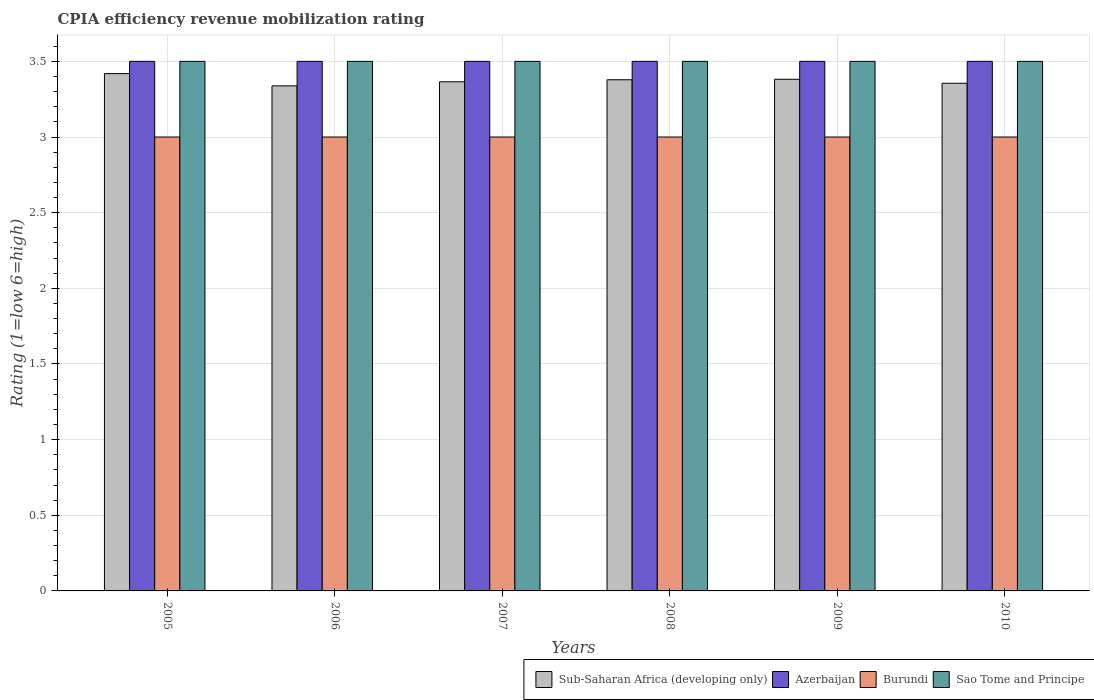How many different coloured bars are there?
Make the answer very short. 4. How many groups of bars are there?
Keep it short and to the point. 6. How many bars are there on the 5th tick from the right?
Provide a short and direct response. 4. What is the label of the 4th group of bars from the left?
Offer a very short reply. 2008. What is the CPIA rating in Sub-Saharan Africa (developing only) in 2008?
Offer a very short reply. 3.38. In which year was the CPIA rating in Sub-Saharan Africa (developing only) maximum?
Provide a succinct answer. 2005. In which year was the CPIA rating in Azerbaijan minimum?
Your answer should be very brief. 2005. What is the total CPIA rating in Sub-Saharan Africa (developing only) in the graph?
Keep it short and to the point. 20.24. What is the difference between the CPIA rating in Sub-Saharan Africa (developing only) in 2007 and that in 2009?
Offer a very short reply. -0.02. What is the difference between the CPIA rating in Burundi in 2008 and the CPIA rating in Sub-Saharan Africa (developing only) in 2010?
Your answer should be compact. -0.36. What is the average CPIA rating in Sub-Saharan Africa (developing only) per year?
Give a very brief answer. 3.37. In the year 2009, what is the difference between the CPIA rating in Burundi and CPIA rating in Sub-Saharan Africa (developing only)?
Offer a terse response. -0.38. What is the difference between the highest and the second highest CPIA rating in Sub-Saharan Africa (developing only)?
Your answer should be very brief. 0.04. Is it the case that in every year, the sum of the CPIA rating in Azerbaijan and CPIA rating in Sao Tome and Principe is greater than the sum of CPIA rating in Sub-Saharan Africa (developing only) and CPIA rating in Burundi?
Provide a short and direct response. Yes. What does the 4th bar from the left in 2009 represents?
Offer a very short reply. Sao Tome and Principe. What does the 2nd bar from the right in 2005 represents?
Provide a succinct answer. Burundi. How many years are there in the graph?
Offer a very short reply. 6. Does the graph contain any zero values?
Ensure brevity in your answer.  No. Does the graph contain grids?
Ensure brevity in your answer.  Yes. What is the title of the graph?
Your answer should be compact. CPIA efficiency revenue mobilization rating. Does "Timor-Leste" appear as one of the legend labels in the graph?
Provide a short and direct response. No. What is the label or title of the X-axis?
Your response must be concise. Years. What is the label or title of the Y-axis?
Provide a succinct answer. Rating (1=low 6=high). What is the Rating (1=low 6=high) of Sub-Saharan Africa (developing only) in 2005?
Your answer should be compact. 3.42. What is the Rating (1=low 6=high) in Burundi in 2005?
Provide a succinct answer. 3. What is the Rating (1=low 6=high) of Sao Tome and Principe in 2005?
Your response must be concise. 3.5. What is the Rating (1=low 6=high) of Sub-Saharan Africa (developing only) in 2006?
Your answer should be very brief. 3.34. What is the Rating (1=low 6=high) of Burundi in 2006?
Make the answer very short. 3. What is the Rating (1=low 6=high) of Sub-Saharan Africa (developing only) in 2007?
Make the answer very short. 3.36. What is the Rating (1=low 6=high) in Sao Tome and Principe in 2007?
Give a very brief answer. 3.5. What is the Rating (1=low 6=high) of Sub-Saharan Africa (developing only) in 2008?
Your answer should be compact. 3.38. What is the Rating (1=low 6=high) of Azerbaijan in 2008?
Keep it short and to the point. 3.5. What is the Rating (1=low 6=high) of Burundi in 2008?
Ensure brevity in your answer.  3. What is the Rating (1=low 6=high) of Sub-Saharan Africa (developing only) in 2009?
Provide a short and direct response. 3.38. What is the Rating (1=low 6=high) of Azerbaijan in 2009?
Keep it short and to the point. 3.5. What is the Rating (1=low 6=high) of Burundi in 2009?
Keep it short and to the point. 3. What is the Rating (1=low 6=high) of Sub-Saharan Africa (developing only) in 2010?
Your answer should be compact. 3.36. What is the Rating (1=low 6=high) in Azerbaijan in 2010?
Your response must be concise. 3.5. What is the Rating (1=low 6=high) in Sao Tome and Principe in 2010?
Offer a very short reply. 3.5. Across all years, what is the maximum Rating (1=low 6=high) in Sub-Saharan Africa (developing only)?
Offer a very short reply. 3.42. Across all years, what is the maximum Rating (1=low 6=high) of Burundi?
Ensure brevity in your answer.  3. Across all years, what is the minimum Rating (1=low 6=high) in Sub-Saharan Africa (developing only)?
Provide a succinct answer. 3.34. Across all years, what is the minimum Rating (1=low 6=high) of Sao Tome and Principe?
Your answer should be very brief. 3.5. What is the total Rating (1=low 6=high) of Sub-Saharan Africa (developing only) in the graph?
Give a very brief answer. 20.24. What is the total Rating (1=low 6=high) of Burundi in the graph?
Your answer should be very brief. 18. What is the total Rating (1=low 6=high) in Sao Tome and Principe in the graph?
Provide a succinct answer. 21. What is the difference between the Rating (1=low 6=high) in Sub-Saharan Africa (developing only) in 2005 and that in 2006?
Ensure brevity in your answer.  0.08. What is the difference between the Rating (1=low 6=high) in Azerbaijan in 2005 and that in 2006?
Make the answer very short. 0. What is the difference between the Rating (1=low 6=high) of Sub-Saharan Africa (developing only) in 2005 and that in 2007?
Provide a short and direct response. 0.05. What is the difference between the Rating (1=low 6=high) of Azerbaijan in 2005 and that in 2007?
Offer a very short reply. 0. What is the difference between the Rating (1=low 6=high) in Sub-Saharan Africa (developing only) in 2005 and that in 2008?
Your answer should be compact. 0.04. What is the difference between the Rating (1=low 6=high) of Burundi in 2005 and that in 2008?
Offer a very short reply. 0. What is the difference between the Rating (1=low 6=high) of Sao Tome and Principe in 2005 and that in 2008?
Your answer should be compact. 0. What is the difference between the Rating (1=low 6=high) of Sub-Saharan Africa (developing only) in 2005 and that in 2009?
Make the answer very short. 0.04. What is the difference between the Rating (1=low 6=high) of Sao Tome and Principe in 2005 and that in 2009?
Your answer should be very brief. 0. What is the difference between the Rating (1=low 6=high) in Sub-Saharan Africa (developing only) in 2005 and that in 2010?
Your answer should be compact. 0.06. What is the difference between the Rating (1=low 6=high) in Sub-Saharan Africa (developing only) in 2006 and that in 2007?
Offer a terse response. -0.03. What is the difference between the Rating (1=low 6=high) of Azerbaijan in 2006 and that in 2007?
Your response must be concise. 0. What is the difference between the Rating (1=low 6=high) of Burundi in 2006 and that in 2007?
Provide a succinct answer. 0. What is the difference between the Rating (1=low 6=high) in Sao Tome and Principe in 2006 and that in 2007?
Keep it short and to the point. 0. What is the difference between the Rating (1=low 6=high) in Sub-Saharan Africa (developing only) in 2006 and that in 2008?
Your answer should be very brief. -0.04. What is the difference between the Rating (1=low 6=high) of Sao Tome and Principe in 2006 and that in 2008?
Your response must be concise. 0. What is the difference between the Rating (1=low 6=high) in Sub-Saharan Africa (developing only) in 2006 and that in 2009?
Offer a very short reply. -0.04. What is the difference between the Rating (1=low 6=high) of Burundi in 2006 and that in 2009?
Offer a very short reply. 0. What is the difference between the Rating (1=low 6=high) in Sao Tome and Principe in 2006 and that in 2009?
Give a very brief answer. 0. What is the difference between the Rating (1=low 6=high) of Sub-Saharan Africa (developing only) in 2006 and that in 2010?
Provide a short and direct response. -0.02. What is the difference between the Rating (1=low 6=high) of Azerbaijan in 2006 and that in 2010?
Your answer should be compact. 0. What is the difference between the Rating (1=low 6=high) in Burundi in 2006 and that in 2010?
Provide a succinct answer. 0. What is the difference between the Rating (1=low 6=high) in Sao Tome and Principe in 2006 and that in 2010?
Offer a terse response. 0. What is the difference between the Rating (1=low 6=high) in Sub-Saharan Africa (developing only) in 2007 and that in 2008?
Keep it short and to the point. -0.01. What is the difference between the Rating (1=low 6=high) of Azerbaijan in 2007 and that in 2008?
Ensure brevity in your answer.  0. What is the difference between the Rating (1=low 6=high) of Sub-Saharan Africa (developing only) in 2007 and that in 2009?
Ensure brevity in your answer.  -0.02. What is the difference between the Rating (1=low 6=high) in Azerbaijan in 2007 and that in 2009?
Your answer should be compact. 0. What is the difference between the Rating (1=low 6=high) in Burundi in 2007 and that in 2009?
Keep it short and to the point. 0. What is the difference between the Rating (1=low 6=high) in Sao Tome and Principe in 2007 and that in 2009?
Give a very brief answer. 0. What is the difference between the Rating (1=low 6=high) of Sub-Saharan Africa (developing only) in 2007 and that in 2010?
Offer a very short reply. 0.01. What is the difference between the Rating (1=low 6=high) in Azerbaijan in 2007 and that in 2010?
Your response must be concise. 0. What is the difference between the Rating (1=low 6=high) in Sub-Saharan Africa (developing only) in 2008 and that in 2009?
Ensure brevity in your answer.  -0. What is the difference between the Rating (1=low 6=high) in Sub-Saharan Africa (developing only) in 2008 and that in 2010?
Your response must be concise. 0.02. What is the difference between the Rating (1=low 6=high) in Burundi in 2008 and that in 2010?
Your answer should be very brief. 0. What is the difference between the Rating (1=low 6=high) in Sub-Saharan Africa (developing only) in 2009 and that in 2010?
Give a very brief answer. 0.03. What is the difference between the Rating (1=low 6=high) in Azerbaijan in 2009 and that in 2010?
Make the answer very short. 0. What is the difference between the Rating (1=low 6=high) of Sub-Saharan Africa (developing only) in 2005 and the Rating (1=low 6=high) of Azerbaijan in 2006?
Offer a terse response. -0.08. What is the difference between the Rating (1=low 6=high) of Sub-Saharan Africa (developing only) in 2005 and the Rating (1=low 6=high) of Burundi in 2006?
Make the answer very short. 0.42. What is the difference between the Rating (1=low 6=high) in Sub-Saharan Africa (developing only) in 2005 and the Rating (1=low 6=high) in Sao Tome and Principe in 2006?
Offer a very short reply. -0.08. What is the difference between the Rating (1=low 6=high) in Azerbaijan in 2005 and the Rating (1=low 6=high) in Sao Tome and Principe in 2006?
Your response must be concise. 0. What is the difference between the Rating (1=low 6=high) of Burundi in 2005 and the Rating (1=low 6=high) of Sao Tome and Principe in 2006?
Provide a short and direct response. -0.5. What is the difference between the Rating (1=low 6=high) in Sub-Saharan Africa (developing only) in 2005 and the Rating (1=low 6=high) in Azerbaijan in 2007?
Offer a terse response. -0.08. What is the difference between the Rating (1=low 6=high) of Sub-Saharan Africa (developing only) in 2005 and the Rating (1=low 6=high) of Burundi in 2007?
Your answer should be compact. 0.42. What is the difference between the Rating (1=low 6=high) of Sub-Saharan Africa (developing only) in 2005 and the Rating (1=low 6=high) of Sao Tome and Principe in 2007?
Offer a very short reply. -0.08. What is the difference between the Rating (1=low 6=high) in Azerbaijan in 2005 and the Rating (1=low 6=high) in Burundi in 2007?
Your response must be concise. 0.5. What is the difference between the Rating (1=low 6=high) in Azerbaijan in 2005 and the Rating (1=low 6=high) in Sao Tome and Principe in 2007?
Give a very brief answer. 0. What is the difference between the Rating (1=low 6=high) in Burundi in 2005 and the Rating (1=low 6=high) in Sao Tome and Principe in 2007?
Your answer should be very brief. -0.5. What is the difference between the Rating (1=low 6=high) in Sub-Saharan Africa (developing only) in 2005 and the Rating (1=low 6=high) in Azerbaijan in 2008?
Keep it short and to the point. -0.08. What is the difference between the Rating (1=low 6=high) of Sub-Saharan Africa (developing only) in 2005 and the Rating (1=low 6=high) of Burundi in 2008?
Keep it short and to the point. 0.42. What is the difference between the Rating (1=low 6=high) of Sub-Saharan Africa (developing only) in 2005 and the Rating (1=low 6=high) of Sao Tome and Principe in 2008?
Keep it short and to the point. -0.08. What is the difference between the Rating (1=low 6=high) in Azerbaijan in 2005 and the Rating (1=low 6=high) in Burundi in 2008?
Your answer should be very brief. 0.5. What is the difference between the Rating (1=low 6=high) of Burundi in 2005 and the Rating (1=low 6=high) of Sao Tome and Principe in 2008?
Offer a terse response. -0.5. What is the difference between the Rating (1=low 6=high) in Sub-Saharan Africa (developing only) in 2005 and the Rating (1=low 6=high) in Azerbaijan in 2009?
Ensure brevity in your answer.  -0.08. What is the difference between the Rating (1=low 6=high) in Sub-Saharan Africa (developing only) in 2005 and the Rating (1=low 6=high) in Burundi in 2009?
Make the answer very short. 0.42. What is the difference between the Rating (1=low 6=high) of Sub-Saharan Africa (developing only) in 2005 and the Rating (1=low 6=high) of Sao Tome and Principe in 2009?
Ensure brevity in your answer.  -0.08. What is the difference between the Rating (1=low 6=high) of Sub-Saharan Africa (developing only) in 2005 and the Rating (1=low 6=high) of Azerbaijan in 2010?
Your answer should be compact. -0.08. What is the difference between the Rating (1=low 6=high) of Sub-Saharan Africa (developing only) in 2005 and the Rating (1=low 6=high) of Burundi in 2010?
Provide a succinct answer. 0.42. What is the difference between the Rating (1=low 6=high) of Sub-Saharan Africa (developing only) in 2005 and the Rating (1=low 6=high) of Sao Tome and Principe in 2010?
Give a very brief answer. -0.08. What is the difference between the Rating (1=low 6=high) in Azerbaijan in 2005 and the Rating (1=low 6=high) in Burundi in 2010?
Your answer should be compact. 0.5. What is the difference between the Rating (1=low 6=high) in Burundi in 2005 and the Rating (1=low 6=high) in Sao Tome and Principe in 2010?
Keep it short and to the point. -0.5. What is the difference between the Rating (1=low 6=high) of Sub-Saharan Africa (developing only) in 2006 and the Rating (1=low 6=high) of Azerbaijan in 2007?
Provide a succinct answer. -0.16. What is the difference between the Rating (1=low 6=high) in Sub-Saharan Africa (developing only) in 2006 and the Rating (1=low 6=high) in Burundi in 2007?
Make the answer very short. 0.34. What is the difference between the Rating (1=low 6=high) in Sub-Saharan Africa (developing only) in 2006 and the Rating (1=low 6=high) in Sao Tome and Principe in 2007?
Your answer should be very brief. -0.16. What is the difference between the Rating (1=low 6=high) in Azerbaijan in 2006 and the Rating (1=low 6=high) in Burundi in 2007?
Provide a succinct answer. 0.5. What is the difference between the Rating (1=low 6=high) in Sub-Saharan Africa (developing only) in 2006 and the Rating (1=low 6=high) in Azerbaijan in 2008?
Offer a very short reply. -0.16. What is the difference between the Rating (1=low 6=high) of Sub-Saharan Africa (developing only) in 2006 and the Rating (1=low 6=high) of Burundi in 2008?
Your response must be concise. 0.34. What is the difference between the Rating (1=low 6=high) in Sub-Saharan Africa (developing only) in 2006 and the Rating (1=low 6=high) in Sao Tome and Principe in 2008?
Offer a terse response. -0.16. What is the difference between the Rating (1=low 6=high) in Azerbaijan in 2006 and the Rating (1=low 6=high) in Sao Tome and Principe in 2008?
Offer a very short reply. 0. What is the difference between the Rating (1=low 6=high) in Sub-Saharan Africa (developing only) in 2006 and the Rating (1=low 6=high) in Azerbaijan in 2009?
Provide a succinct answer. -0.16. What is the difference between the Rating (1=low 6=high) of Sub-Saharan Africa (developing only) in 2006 and the Rating (1=low 6=high) of Burundi in 2009?
Your answer should be very brief. 0.34. What is the difference between the Rating (1=low 6=high) of Sub-Saharan Africa (developing only) in 2006 and the Rating (1=low 6=high) of Sao Tome and Principe in 2009?
Keep it short and to the point. -0.16. What is the difference between the Rating (1=low 6=high) of Azerbaijan in 2006 and the Rating (1=low 6=high) of Burundi in 2009?
Keep it short and to the point. 0.5. What is the difference between the Rating (1=low 6=high) of Burundi in 2006 and the Rating (1=low 6=high) of Sao Tome and Principe in 2009?
Offer a terse response. -0.5. What is the difference between the Rating (1=low 6=high) in Sub-Saharan Africa (developing only) in 2006 and the Rating (1=low 6=high) in Azerbaijan in 2010?
Your answer should be very brief. -0.16. What is the difference between the Rating (1=low 6=high) in Sub-Saharan Africa (developing only) in 2006 and the Rating (1=low 6=high) in Burundi in 2010?
Your response must be concise. 0.34. What is the difference between the Rating (1=low 6=high) in Sub-Saharan Africa (developing only) in 2006 and the Rating (1=low 6=high) in Sao Tome and Principe in 2010?
Keep it short and to the point. -0.16. What is the difference between the Rating (1=low 6=high) in Azerbaijan in 2006 and the Rating (1=low 6=high) in Burundi in 2010?
Offer a very short reply. 0.5. What is the difference between the Rating (1=low 6=high) of Azerbaijan in 2006 and the Rating (1=low 6=high) of Sao Tome and Principe in 2010?
Make the answer very short. 0. What is the difference between the Rating (1=low 6=high) of Burundi in 2006 and the Rating (1=low 6=high) of Sao Tome and Principe in 2010?
Provide a succinct answer. -0.5. What is the difference between the Rating (1=low 6=high) in Sub-Saharan Africa (developing only) in 2007 and the Rating (1=low 6=high) in Azerbaijan in 2008?
Provide a succinct answer. -0.14. What is the difference between the Rating (1=low 6=high) of Sub-Saharan Africa (developing only) in 2007 and the Rating (1=low 6=high) of Burundi in 2008?
Ensure brevity in your answer.  0.36. What is the difference between the Rating (1=low 6=high) of Sub-Saharan Africa (developing only) in 2007 and the Rating (1=low 6=high) of Sao Tome and Principe in 2008?
Make the answer very short. -0.14. What is the difference between the Rating (1=low 6=high) in Azerbaijan in 2007 and the Rating (1=low 6=high) in Burundi in 2008?
Keep it short and to the point. 0.5. What is the difference between the Rating (1=low 6=high) of Azerbaijan in 2007 and the Rating (1=low 6=high) of Sao Tome and Principe in 2008?
Keep it short and to the point. 0. What is the difference between the Rating (1=low 6=high) in Sub-Saharan Africa (developing only) in 2007 and the Rating (1=low 6=high) in Azerbaijan in 2009?
Your answer should be very brief. -0.14. What is the difference between the Rating (1=low 6=high) of Sub-Saharan Africa (developing only) in 2007 and the Rating (1=low 6=high) of Burundi in 2009?
Offer a terse response. 0.36. What is the difference between the Rating (1=low 6=high) in Sub-Saharan Africa (developing only) in 2007 and the Rating (1=low 6=high) in Sao Tome and Principe in 2009?
Give a very brief answer. -0.14. What is the difference between the Rating (1=low 6=high) of Sub-Saharan Africa (developing only) in 2007 and the Rating (1=low 6=high) of Azerbaijan in 2010?
Offer a terse response. -0.14. What is the difference between the Rating (1=low 6=high) of Sub-Saharan Africa (developing only) in 2007 and the Rating (1=low 6=high) of Burundi in 2010?
Your answer should be very brief. 0.36. What is the difference between the Rating (1=low 6=high) of Sub-Saharan Africa (developing only) in 2007 and the Rating (1=low 6=high) of Sao Tome and Principe in 2010?
Ensure brevity in your answer.  -0.14. What is the difference between the Rating (1=low 6=high) in Burundi in 2007 and the Rating (1=low 6=high) in Sao Tome and Principe in 2010?
Your answer should be very brief. -0.5. What is the difference between the Rating (1=low 6=high) of Sub-Saharan Africa (developing only) in 2008 and the Rating (1=low 6=high) of Azerbaijan in 2009?
Your response must be concise. -0.12. What is the difference between the Rating (1=low 6=high) in Sub-Saharan Africa (developing only) in 2008 and the Rating (1=low 6=high) in Burundi in 2009?
Your response must be concise. 0.38. What is the difference between the Rating (1=low 6=high) of Sub-Saharan Africa (developing only) in 2008 and the Rating (1=low 6=high) of Sao Tome and Principe in 2009?
Keep it short and to the point. -0.12. What is the difference between the Rating (1=low 6=high) of Azerbaijan in 2008 and the Rating (1=low 6=high) of Burundi in 2009?
Offer a very short reply. 0.5. What is the difference between the Rating (1=low 6=high) of Azerbaijan in 2008 and the Rating (1=low 6=high) of Sao Tome and Principe in 2009?
Your response must be concise. 0. What is the difference between the Rating (1=low 6=high) in Sub-Saharan Africa (developing only) in 2008 and the Rating (1=low 6=high) in Azerbaijan in 2010?
Your answer should be very brief. -0.12. What is the difference between the Rating (1=low 6=high) of Sub-Saharan Africa (developing only) in 2008 and the Rating (1=low 6=high) of Burundi in 2010?
Give a very brief answer. 0.38. What is the difference between the Rating (1=low 6=high) of Sub-Saharan Africa (developing only) in 2008 and the Rating (1=low 6=high) of Sao Tome and Principe in 2010?
Offer a very short reply. -0.12. What is the difference between the Rating (1=low 6=high) of Azerbaijan in 2008 and the Rating (1=low 6=high) of Sao Tome and Principe in 2010?
Provide a short and direct response. 0. What is the difference between the Rating (1=low 6=high) of Sub-Saharan Africa (developing only) in 2009 and the Rating (1=low 6=high) of Azerbaijan in 2010?
Your answer should be compact. -0.12. What is the difference between the Rating (1=low 6=high) in Sub-Saharan Africa (developing only) in 2009 and the Rating (1=low 6=high) in Burundi in 2010?
Your answer should be very brief. 0.38. What is the difference between the Rating (1=low 6=high) in Sub-Saharan Africa (developing only) in 2009 and the Rating (1=low 6=high) in Sao Tome and Principe in 2010?
Provide a succinct answer. -0.12. What is the difference between the Rating (1=low 6=high) in Azerbaijan in 2009 and the Rating (1=low 6=high) in Burundi in 2010?
Keep it short and to the point. 0.5. What is the difference between the Rating (1=low 6=high) of Burundi in 2009 and the Rating (1=low 6=high) of Sao Tome and Principe in 2010?
Your answer should be very brief. -0.5. What is the average Rating (1=low 6=high) of Sub-Saharan Africa (developing only) per year?
Your response must be concise. 3.37. What is the average Rating (1=low 6=high) in Azerbaijan per year?
Give a very brief answer. 3.5. What is the average Rating (1=low 6=high) in Burundi per year?
Your answer should be very brief. 3. What is the average Rating (1=low 6=high) of Sao Tome and Principe per year?
Your answer should be very brief. 3.5. In the year 2005, what is the difference between the Rating (1=low 6=high) in Sub-Saharan Africa (developing only) and Rating (1=low 6=high) in Azerbaijan?
Your answer should be very brief. -0.08. In the year 2005, what is the difference between the Rating (1=low 6=high) in Sub-Saharan Africa (developing only) and Rating (1=low 6=high) in Burundi?
Make the answer very short. 0.42. In the year 2005, what is the difference between the Rating (1=low 6=high) in Sub-Saharan Africa (developing only) and Rating (1=low 6=high) in Sao Tome and Principe?
Your response must be concise. -0.08. In the year 2006, what is the difference between the Rating (1=low 6=high) in Sub-Saharan Africa (developing only) and Rating (1=low 6=high) in Azerbaijan?
Provide a succinct answer. -0.16. In the year 2006, what is the difference between the Rating (1=low 6=high) of Sub-Saharan Africa (developing only) and Rating (1=low 6=high) of Burundi?
Your answer should be compact. 0.34. In the year 2006, what is the difference between the Rating (1=low 6=high) in Sub-Saharan Africa (developing only) and Rating (1=low 6=high) in Sao Tome and Principe?
Ensure brevity in your answer.  -0.16. In the year 2006, what is the difference between the Rating (1=low 6=high) of Azerbaijan and Rating (1=low 6=high) of Burundi?
Your answer should be very brief. 0.5. In the year 2006, what is the difference between the Rating (1=low 6=high) in Azerbaijan and Rating (1=low 6=high) in Sao Tome and Principe?
Your response must be concise. 0. In the year 2006, what is the difference between the Rating (1=low 6=high) of Burundi and Rating (1=low 6=high) of Sao Tome and Principe?
Keep it short and to the point. -0.5. In the year 2007, what is the difference between the Rating (1=low 6=high) in Sub-Saharan Africa (developing only) and Rating (1=low 6=high) in Azerbaijan?
Offer a very short reply. -0.14. In the year 2007, what is the difference between the Rating (1=low 6=high) of Sub-Saharan Africa (developing only) and Rating (1=low 6=high) of Burundi?
Offer a very short reply. 0.36. In the year 2007, what is the difference between the Rating (1=low 6=high) of Sub-Saharan Africa (developing only) and Rating (1=low 6=high) of Sao Tome and Principe?
Provide a succinct answer. -0.14. In the year 2007, what is the difference between the Rating (1=low 6=high) in Burundi and Rating (1=low 6=high) in Sao Tome and Principe?
Provide a succinct answer. -0.5. In the year 2008, what is the difference between the Rating (1=low 6=high) in Sub-Saharan Africa (developing only) and Rating (1=low 6=high) in Azerbaijan?
Keep it short and to the point. -0.12. In the year 2008, what is the difference between the Rating (1=low 6=high) of Sub-Saharan Africa (developing only) and Rating (1=low 6=high) of Burundi?
Give a very brief answer. 0.38. In the year 2008, what is the difference between the Rating (1=low 6=high) of Sub-Saharan Africa (developing only) and Rating (1=low 6=high) of Sao Tome and Principe?
Your answer should be very brief. -0.12. In the year 2008, what is the difference between the Rating (1=low 6=high) in Azerbaijan and Rating (1=low 6=high) in Sao Tome and Principe?
Give a very brief answer. 0. In the year 2009, what is the difference between the Rating (1=low 6=high) of Sub-Saharan Africa (developing only) and Rating (1=low 6=high) of Azerbaijan?
Offer a very short reply. -0.12. In the year 2009, what is the difference between the Rating (1=low 6=high) in Sub-Saharan Africa (developing only) and Rating (1=low 6=high) in Burundi?
Offer a terse response. 0.38. In the year 2009, what is the difference between the Rating (1=low 6=high) of Sub-Saharan Africa (developing only) and Rating (1=low 6=high) of Sao Tome and Principe?
Offer a terse response. -0.12. In the year 2009, what is the difference between the Rating (1=low 6=high) of Azerbaijan and Rating (1=low 6=high) of Sao Tome and Principe?
Your answer should be very brief. 0. In the year 2010, what is the difference between the Rating (1=low 6=high) of Sub-Saharan Africa (developing only) and Rating (1=low 6=high) of Azerbaijan?
Provide a succinct answer. -0.14. In the year 2010, what is the difference between the Rating (1=low 6=high) in Sub-Saharan Africa (developing only) and Rating (1=low 6=high) in Burundi?
Keep it short and to the point. 0.36. In the year 2010, what is the difference between the Rating (1=low 6=high) of Sub-Saharan Africa (developing only) and Rating (1=low 6=high) of Sao Tome and Principe?
Provide a succinct answer. -0.14. In the year 2010, what is the difference between the Rating (1=low 6=high) of Azerbaijan and Rating (1=low 6=high) of Burundi?
Ensure brevity in your answer.  0.5. In the year 2010, what is the difference between the Rating (1=low 6=high) in Azerbaijan and Rating (1=low 6=high) in Sao Tome and Principe?
Your answer should be compact. 0. What is the ratio of the Rating (1=low 6=high) in Sub-Saharan Africa (developing only) in 2005 to that in 2006?
Your answer should be very brief. 1.02. What is the ratio of the Rating (1=low 6=high) in Sao Tome and Principe in 2005 to that in 2006?
Ensure brevity in your answer.  1. What is the ratio of the Rating (1=low 6=high) in Sub-Saharan Africa (developing only) in 2005 to that in 2007?
Your answer should be very brief. 1.02. What is the ratio of the Rating (1=low 6=high) of Burundi in 2005 to that in 2007?
Provide a short and direct response. 1. What is the ratio of the Rating (1=low 6=high) of Sao Tome and Principe in 2005 to that in 2007?
Offer a very short reply. 1. What is the ratio of the Rating (1=low 6=high) in Sub-Saharan Africa (developing only) in 2005 to that in 2008?
Offer a terse response. 1.01. What is the ratio of the Rating (1=low 6=high) in Azerbaijan in 2005 to that in 2008?
Offer a terse response. 1. What is the ratio of the Rating (1=low 6=high) in Burundi in 2005 to that in 2008?
Give a very brief answer. 1. What is the ratio of the Rating (1=low 6=high) in Sao Tome and Principe in 2005 to that in 2008?
Give a very brief answer. 1. What is the ratio of the Rating (1=low 6=high) in Sub-Saharan Africa (developing only) in 2005 to that in 2009?
Your answer should be compact. 1.01. What is the ratio of the Rating (1=low 6=high) in Burundi in 2005 to that in 2009?
Make the answer very short. 1. What is the ratio of the Rating (1=low 6=high) of Azerbaijan in 2005 to that in 2010?
Ensure brevity in your answer.  1. What is the ratio of the Rating (1=low 6=high) of Burundi in 2005 to that in 2010?
Your response must be concise. 1. What is the ratio of the Rating (1=low 6=high) of Sao Tome and Principe in 2005 to that in 2010?
Give a very brief answer. 1. What is the ratio of the Rating (1=low 6=high) in Burundi in 2006 to that in 2007?
Make the answer very short. 1. What is the ratio of the Rating (1=low 6=high) of Sub-Saharan Africa (developing only) in 2006 to that in 2008?
Provide a succinct answer. 0.99. What is the ratio of the Rating (1=low 6=high) of Azerbaijan in 2006 to that in 2008?
Your answer should be very brief. 1. What is the ratio of the Rating (1=low 6=high) of Sao Tome and Principe in 2006 to that in 2008?
Provide a short and direct response. 1. What is the ratio of the Rating (1=low 6=high) of Sub-Saharan Africa (developing only) in 2006 to that in 2009?
Provide a succinct answer. 0.99. What is the ratio of the Rating (1=low 6=high) in Azerbaijan in 2006 to that in 2009?
Give a very brief answer. 1. What is the ratio of the Rating (1=low 6=high) in Burundi in 2006 to that in 2009?
Keep it short and to the point. 1. What is the ratio of the Rating (1=low 6=high) in Sao Tome and Principe in 2006 to that in 2009?
Make the answer very short. 1. What is the ratio of the Rating (1=low 6=high) in Sub-Saharan Africa (developing only) in 2006 to that in 2010?
Give a very brief answer. 0.99. What is the ratio of the Rating (1=low 6=high) in Azerbaijan in 2006 to that in 2010?
Ensure brevity in your answer.  1. What is the ratio of the Rating (1=low 6=high) of Burundi in 2006 to that in 2010?
Your response must be concise. 1. What is the ratio of the Rating (1=low 6=high) of Sub-Saharan Africa (developing only) in 2007 to that in 2008?
Provide a succinct answer. 1. What is the ratio of the Rating (1=low 6=high) in Azerbaijan in 2007 to that in 2008?
Provide a short and direct response. 1. What is the ratio of the Rating (1=low 6=high) of Sao Tome and Principe in 2007 to that in 2008?
Provide a short and direct response. 1. What is the ratio of the Rating (1=low 6=high) in Sub-Saharan Africa (developing only) in 2007 to that in 2009?
Your response must be concise. 1. What is the ratio of the Rating (1=low 6=high) of Sao Tome and Principe in 2007 to that in 2009?
Provide a succinct answer. 1. What is the ratio of the Rating (1=low 6=high) in Sub-Saharan Africa (developing only) in 2007 to that in 2010?
Your answer should be compact. 1. What is the ratio of the Rating (1=low 6=high) of Azerbaijan in 2008 to that in 2009?
Ensure brevity in your answer.  1. What is the ratio of the Rating (1=low 6=high) in Sao Tome and Principe in 2008 to that in 2009?
Your answer should be very brief. 1. What is the ratio of the Rating (1=low 6=high) of Sub-Saharan Africa (developing only) in 2008 to that in 2010?
Offer a very short reply. 1.01. What is the ratio of the Rating (1=low 6=high) in Sub-Saharan Africa (developing only) in 2009 to that in 2010?
Provide a short and direct response. 1.01. What is the ratio of the Rating (1=low 6=high) of Burundi in 2009 to that in 2010?
Your answer should be very brief. 1. What is the difference between the highest and the second highest Rating (1=low 6=high) of Sub-Saharan Africa (developing only)?
Your answer should be compact. 0.04. What is the difference between the highest and the second highest Rating (1=low 6=high) of Azerbaijan?
Give a very brief answer. 0. What is the difference between the highest and the lowest Rating (1=low 6=high) in Sub-Saharan Africa (developing only)?
Provide a short and direct response. 0.08. What is the difference between the highest and the lowest Rating (1=low 6=high) of Azerbaijan?
Ensure brevity in your answer.  0. 